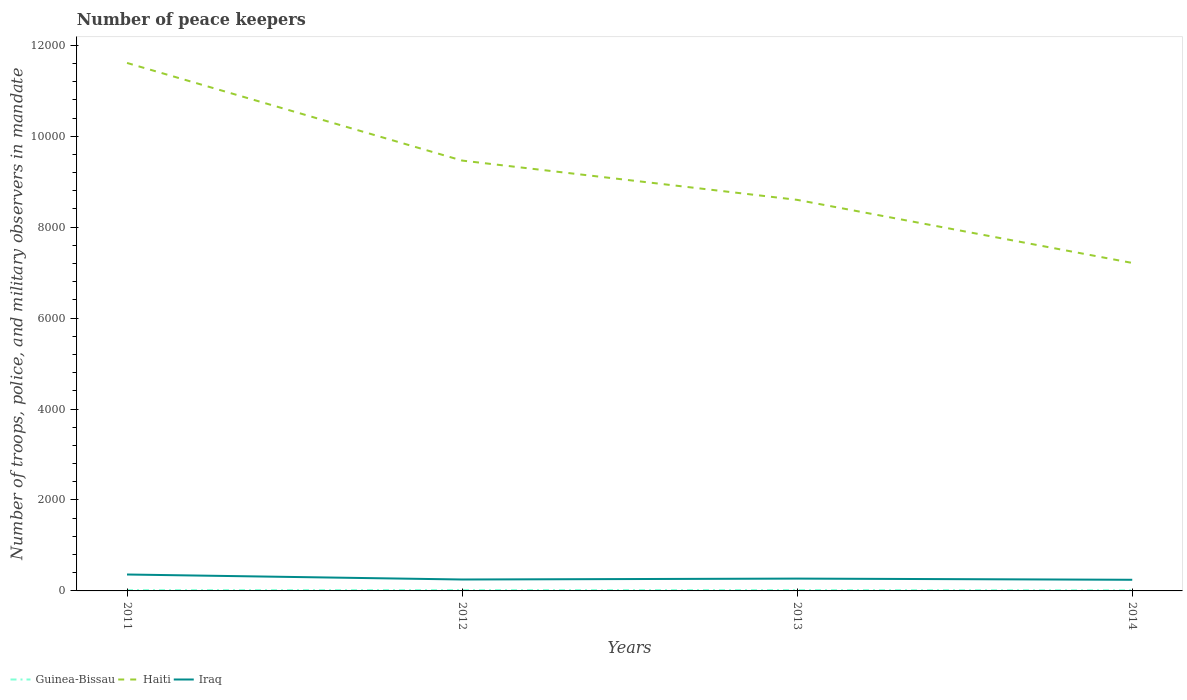How many different coloured lines are there?
Offer a terse response. 3. Does the line corresponding to Guinea-Bissau intersect with the line corresponding to Iraq?
Give a very brief answer. No. In which year was the number of peace keepers in in Iraq maximum?
Offer a terse response. 2014. What is the total number of peace keepers in in Iraq in the graph?
Make the answer very short. 116. What is the difference between the highest and the lowest number of peace keepers in in Iraq?
Your answer should be very brief. 1. How many lines are there?
Keep it short and to the point. 3. What is the difference between two consecutive major ticks on the Y-axis?
Your answer should be very brief. 2000. Does the graph contain grids?
Give a very brief answer. No. Where does the legend appear in the graph?
Give a very brief answer. Bottom left. How many legend labels are there?
Keep it short and to the point. 3. How are the legend labels stacked?
Provide a short and direct response. Horizontal. What is the title of the graph?
Give a very brief answer. Number of peace keepers. Does "Portugal" appear as one of the legend labels in the graph?
Provide a succinct answer. No. What is the label or title of the Y-axis?
Your response must be concise. Number of troops, police, and military observers in mandate. What is the Number of troops, police, and military observers in mandate of Haiti in 2011?
Make the answer very short. 1.16e+04. What is the Number of troops, police, and military observers in mandate in Iraq in 2011?
Offer a very short reply. 361. What is the Number of troops, police, and military observers in mandate in Guinea-Bissau in 2012?
Offer a terse response. 18. What is the Number of troops, police, and military observers in mandate of Haiti in 2012?
Provide a short and direct response. 9464. What is the Number of troops, police, and military observers in mandate in Iraq in 2012?
Your answer should be compact. 251. What is the Number of troops, police, and military observers in mandate in Guinea-Bissau in 2013?
Your answer should be very brief. 18. What is the Number of troops, police, and military observers in mandate in Haiti in 2013?
Make the answer very short. 8600. What is the Number of troops, police, and military observers in mandate of Iraq in 2013?
Offer a very short reply. 271. What is the Number of troops, police, and military observers in mandate in Haiti in 2014?
Your answer should be compact. 7213. What is the Number of troops, police, and military observers in mandate of Iraq in 2014?
Offer a very short reply. 245. Across all years, what is the maximum Number of troops, police, and military observers in mandate of Haiti?
Provide a short and direct response. 1.16e+04. Across all years, what is the maximum Number of troops, police, and military observers in mandate in Iraq?
Offer a very short reply. 361. Across all years, what is the minimum Number of troops, police, and military observers in mandate of Guinea-Bissau?
Make the answer very short. 14. Across all years, what is the minimum Number of troops, police, and military observers in mandate in Haiti?
Make the answer very short. 7213. Across all years, what is the minimum Number of troops, police, and military observers in mandate in Iraq?
Keep it short and to the point. 245. What is the total Number of troops, police, and military observers in mandate of Guinea-Bissau in the graph?
Ensure brevity in your answer.  67. What is the total Number of troops, police, and military observers in mandate in Haiti in the graph?
Give a very brief answer. 3.69e+04. What is the total Number of troops, police, and military observers in mandate of Iraq in the graph?
Ensure brevity in your answer.  1128. What is the difference between the Number of troops, police, and military observers in mandate in Haiti in 2011 and that in 2012?
Provide a succinct answer. 2147. What is the difference between the Number of troops, police, and military observers in mandate of Iraq in 2011 and that in 2012?
Your answer should be very brief. 110. What is the difference between the Number of troops, police, and military observers in mandate in Guinea-Bissau in 2011 and that in 2013?
Your response must be concise. -1. What is the difference between the Number of troops, police, and military observers in mandate in Haiti in 2011 and that in 2013?
Provide a succinct answer. 3011. What is the difference between the Number of troops, police, and military observers in mandate of Iraq in 2011 and that in 2013?
Offer a very short reply. 90. What is the difference between the Number of troops, police, and military observers in mandate of Haiti in 2011 and that in 2014?
Ensure brevity in your answer.  4398. What is the difference between the Number of troops, police, and military observers in mandate in Iraq in 2011 and that in 2014?
Your answer should be compact. 116. What is the difference between the Number of troops, police, and military observers in mandate in Guinea-Bissau in 2012 and that in 2013?
Make the answer very short. 0. What is the difference between the Number of troops, police, and military observers in mandate in Haiti in 2012 and that in 2013?
Offer a terse response. 864. What is the difference between the Number of troops, police, and military observers in mandate of Iraq in 2012 and that in 2013?
Your answer should be very brief. -20. What is the difference between the Number of troops, police, and military observers in mandate in Guinea-Bissau in 2012 and that in 2014?
Your response must be concise. 4. What is the difference between the Number of troops, police, and military observers in mandate in Haiti in 2012 and that in 2014?
Make the answer very short. 2251. What is the difference between the Number of troops, police, and military observers in mandate in Guinea-Bissau in 2013 and that in 2014?
Your response must be concise. 4. What is the difference between the Number of troops, police, and military observers in mandate of Haiti in 2013 and that in 2014?
Make the answer very short. 1387. What is the difference between the Number of troops, police, and military observers in mandate in Iraq in 2013 and that in 2014?
Give a very brief answer. 26. What is the difference between the Number of troops, police, and military observers in mandate in Guinea-Bissau in 2011 and the Number of troops, police, and military observers in mandate in Haiti in 2012?
Keep it short and to the point. -9447. What is the difference between the Number of troops, police, and military observers in mandate in Guinea-Bissau in 2011 and the Number of troops, police, and military observers in mandate in Iraq in 2012?
Ensure brevity in your answer.  -234. What is the difference between the Number of troops, police, and military observers in mandate of Haiti in 2011 and the Number of troops, police, and military observers in mandate of Iraq in 2012?
Your answer should be very brief. 1.14e+04. What is the difference between the Number of troops, police, and military observers in mandate in Guinea-Bissau in 2011 and the Number of troops, police, and military observers in mandate in Haiti in 2013?
Keep it short and to the point. -8583. What is the difference between the Number of troops, police, and military observers in mandate of Guinea-Bissau in 2011 and the Number of troops, police, and military observers in mandate of Iraq in 2013?
Your response must be concise. -254. What is the difference between the Number of troops, police, and military observers in mandate in Haiti in 2011 and the Number of troops, police, and military observers in mandate in Iraq in 2013?
Offer a terse response. 1.13e+04. What is the difference between the Number of troops, police, and military observers in mandate of Guinea-Bissau in 2011 and the Number of troops, police, and military observers in mandate of Haiti in 2014?
Provide a succinct answer. -7196. What is the difference between the Number of troops, police, and military observers in mandate in Guinea-Bissau in 2011 and the Number of troops, police, and military observers in mandate in Iraq in 2014?
Ensure brevity in your answer.  -228. What is the difference between the Number of troops, police, and military observers in mandate of Haiti in 2011 and the Number of troops, police, and military observers in mandate of Iraq in 2014?
Provide a succinct answer. 1.14e+04. What is the difference between the Number of troops, police, and military observers in mandate in Guinea-Bissau in 2012 and the Number of troops, police, and military observers in mandate in Haiti in 2013?
Offer a very short reply. -8582. What is the difference between the Number of troops, police, and military observers in mandate in Guinea-Bissau in 2012 and the Number of troops, police, and military observers in mandate in Iraq in 2013?
Your response must be concise. -253. What is the difference between the Number of troops, police, and military observers in mandate in Haiti in 2012 and the Number of troops, police, and military observers in mandate in Iraq in 2013?
Give a very brief answer. 9193. What is the difference between the Number of troops, police, and military observers in mandate of Guinea-Bissau in 2012 and the Number of troops, police, and military observers in mandate of Haiti in 2014?
Your response must be concise. -7195. What is the difference between the Number of troops, police, and military observers in mandate in Guinea-Bissau in 2012 and the Number of troops, police, and military observers in mandate in Iraq in 2014?
Offer a very short reply. -227. What is the difference between the Number of troops, police, and military observers in mandate in Haiti in 2012 and the Number of troops, police, and military observers in mandate in Iraq in 2014?
Make the answer very short. 9219. What is the difference between the Number of troops, police, and military observers in mandate of Guinea-Bissau in 2013 and the Number of troops, police, and military observers in mandate of Haiti in 2014?
Your answer should be compact. -7195. What is the difference between the Number of troops, police, and military observers in mandate in Guinea-Bissau in 2013 and the Number of troops, police, and military observers in mandate in Iraq in 2014?
Provide a short and direct response. -227. What is the difference between the Number of troops, police, and military observers in mandate of Haiti in 2013 and the Number of troops, police, and military observers in mandate of Iraq in 2014?
Make the answer very short. 8355. What is the average Number of troops, police, and military observers in mandate of Guinea-Bissau per year?
Your answer should be compact. 16.75. What is the average Number of troops, police, and military observers in mandate in Haiti per year?
Provide a succinct answer. 9222. What is the average Number of troops, police, and military observers in mandate in Iraq per year?
Your response must be concise. 282. In the year 2011, what is the difference between the Number of troops, police, and military observers in mandate of Guinea-Bissau and Number of troops, police, and military observers in mandate of Haiti?
Ensure brevity in your answer.  -1.16e+04. In the year 2011, what is the difference between the Number of troops, police, and military observers in mandate of Guinea-Bissau and Number of troops, police, and military observers in mandate of Iraq?
Provide a succinct answer. -344. In the year 2011, what is the difference between the Number of troops, police, and military observers in mandate of Haiti and Number of troops, police, and military observers in mandate of Iraq?
Your answer should be very brief. 1.12e+04. In the year 2012, what is the difference between the Number of troops, police, and military observers in mandate of Guinea-Bissau and Number of troops, police, and military observers in mandate of Haiti?
Your answer should be very brief. -9446. In the year 2012, what is the difference between the Number of troops, police, and military observers in mandate of Guinea-Bissau and Number of troops, police, and military observers in mandate of Iraq?
Provide a succinct answer. -233. In the year 2012, what is the difference between the Number of troops, police, and military observers in mandate in Haiti and Number of troops, police, and military observers in mandate in Iraq?
Provide a short and direct response. 9213. In the year 2013, what is the difference between the Number of troops, police, and military observers in mandate of Guinea-Bissau and Number of troops, police, and military observers in mandate of Haiti?
Your answer should be compact. -8582. In the year 2013, what is the difference between the Number of troops, police, and military observers in mandate of Guinea-Bissau and Number of troops, police, and military observers in mandate of Iraq?
Your response must be concise. -253. In the year 2013, what is the difference between the Number of troops, police, and military observers in mandate in Haiti and Number of troops, police, and military observers in mandate in Iraq?
Your response must be concise. 8329. In the year 2014, what is the difference between the Number of troops, police, and military observers in mandate of Guinea-Bissau and Number of troops, police, and military observers in mandate of Haiti?
Ensure brevity in your answer.  -7199. In the year 2014, what is the difference between the Number of troops, police, and military observers in mandate in Guinea-Bissau and Number of troops, police, and military observers in mandate in Iraq?
Give a very brief answer. -231. In the year 2014, what is the difference between the Number of troops, police, and military observers in mandate of Haiti and Number of troops, police, and military observers in mandate of Iraq?
Your answer should be very brief. 6968. What is the ratio of the Number of troops, police, and military observers in mandate in Haiti in 2011 to that in 2012?
Provide a succinct answer. 1.23. What is the ratio of the Number of troops, police, and military observers in mandate in Iraq in 2011 to that in 2012?
Offer a terse response. 1.44. What is the ratio of the Number of troops, police, and military observers in mandate in Haiti in 2011 to that in 2013?
Offer a very short reply. 1.35. What is the ratio of the Number of troops, police, and military observers in mandate in Iraq in 2011 to that in 2013?
Offer a very short reply. 1.33. What is the ratio of the Number of troops, police, and military observers in mandate of Guinea-Bissau in 2011 to that in 2014?
Give a very brief answer. 1.21. What is the ratio of the Number of troops, police, and military observers in mandate in Haiti in 2011 to that in 2014?
Your answer should be compact. 1.61. What is the ratio of the Number of troops, police, and military observers in mandate of Iraq in 2011 to that in 2014?
Offer a very short reply. 1.47. What is the ratio of the Number of troops, police, and military observers in mandate in Guinea-Bissau in 2012 to that in 2013?
Provide a succinct answer. 1. What is the ratio of the Number of troops, police, and military observers in mandate in Haiti in 2012 to that in 2013?
Provide a short and direct response. 1.1. What is the ratio of the Number of troops, police, and military observers in mandate in Iraq in 2012 to that in 2013?
Offer a terse response. 0.93. What is the ratio of the Number of troops, police, and military observers in mandate in Guinea-Bissau in 2012 to that in 2014?
Your answer should be very brief. 1.29. What is the ratio of the Number of troops, police, and military observers in mandate of Haiti in 2012 to that in 2014?
Give a very brief answer. 1.31. What is the ratio of the Number of troops, police, and military observers in mandate of Iraq in 2012 to that in 2014?
Offer a terse response. 1.02. What is the ratio of the Number of troops, police, and military observers in mandate in Haiti in 2013 to that in 2014?
Your answer should be compact. 1.19. What is the ratio of the Number of troops, police, and military observers in mandate of Iraq in 2013 to that in 2014?
Your answer should be very brief. 1.11. What is the difference between the highest and the second highest Number of troops, police, and military observers in mandate in Haiti?
Give a very brief answer. 2147. What is the difference between the highest and the lowest Number of troops, police, and military observers in mandate of Guinea-Bissau?
Offer a very short reply. 4. What is the difference between the highest and the lowest Number of troops, police, and military observers in mandate of Haiti?
Make the answer very short. 4398. What is the difference between the highest and the lowest Number of troops, police, and military observers in mandate of Iraq?
Offer a very short reply. 116. 